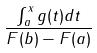<formula> <loc_0><loc_0><loc_500><loc_500>\frac { \int _ { a } ^ { x } g ( t ) d t } { F ( b ) - F ( a ) }</formula> 